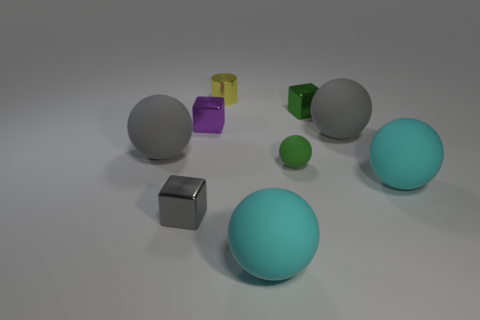There is a green thing that is the same shape as the tiny purple object; what is its size?
Make the answer very short. Small. What number of objects are either cyan matte balls that are on the right side of the tiny gray metallic cube or gray things to the right of the small green rubber object?
Your answer should be compact. 3. There is a rubber thing that is behind the green sphere and on the right side of the tiny green ball; how big is it?
Offer a very short reply. Large. There is a tiny green metallic object; is it the same shape as the big gray matte thing on the left side of the tiny green ball?
Ensure brevity in your answer.  No. What number of things are large balls to the left of the tiny gray block or metallic cubes?
Keep it short and to the point. 4. Is the tiny cylinder made of the same material as the big gray sphere to the right of the green rubber thing?
Offer a very short reply. No. What shape is the gray object behind the gray ball that is left of the purple metallic thing?
Your response must be concise. Sphere. Do the tiny metal cylinder and the tiny shiny thing that is to the right of the tiny matte sphere have the same color?
Your answer should be very brief. No. What is the shape of the yellow shiny thing?
Offer a terse response. Cylinder. What is the size of the gray ball that is on the right side of the yellow cylinder to the left of the tiny green sphere?
Provide a short and direct response. Large. 